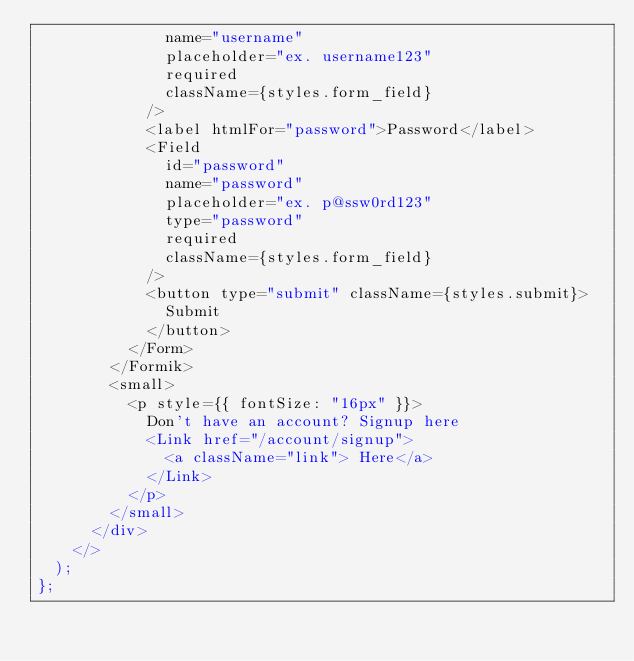Convert code to text. <code><loc_0><loc_0><loc_500><loc_500><_TypeScript_>              name="username"
              placeholder="ex. username123"
              required
              className={styles.form_field}
            />
            <label htmlFor="password">Password</label>
            <Field
              id="password"
              name="password"
              placeholder="ex. p@ssw0rd123"
              type="password"
              required
              className={styles.form_field}
            />
            <button type="submit" className={styles.submit}>
              Submit
            </button>
          </Form>
        </Formik>
        <small>
          <p style={{ fontSize: "16px" }}>
            Don't have an account? Signup here
            <Link href="/account/signup">
              <a className="link"> Here</a>
            </Link>
          </p>
        </small>
      </div>
    </>
  );
};
</code> 